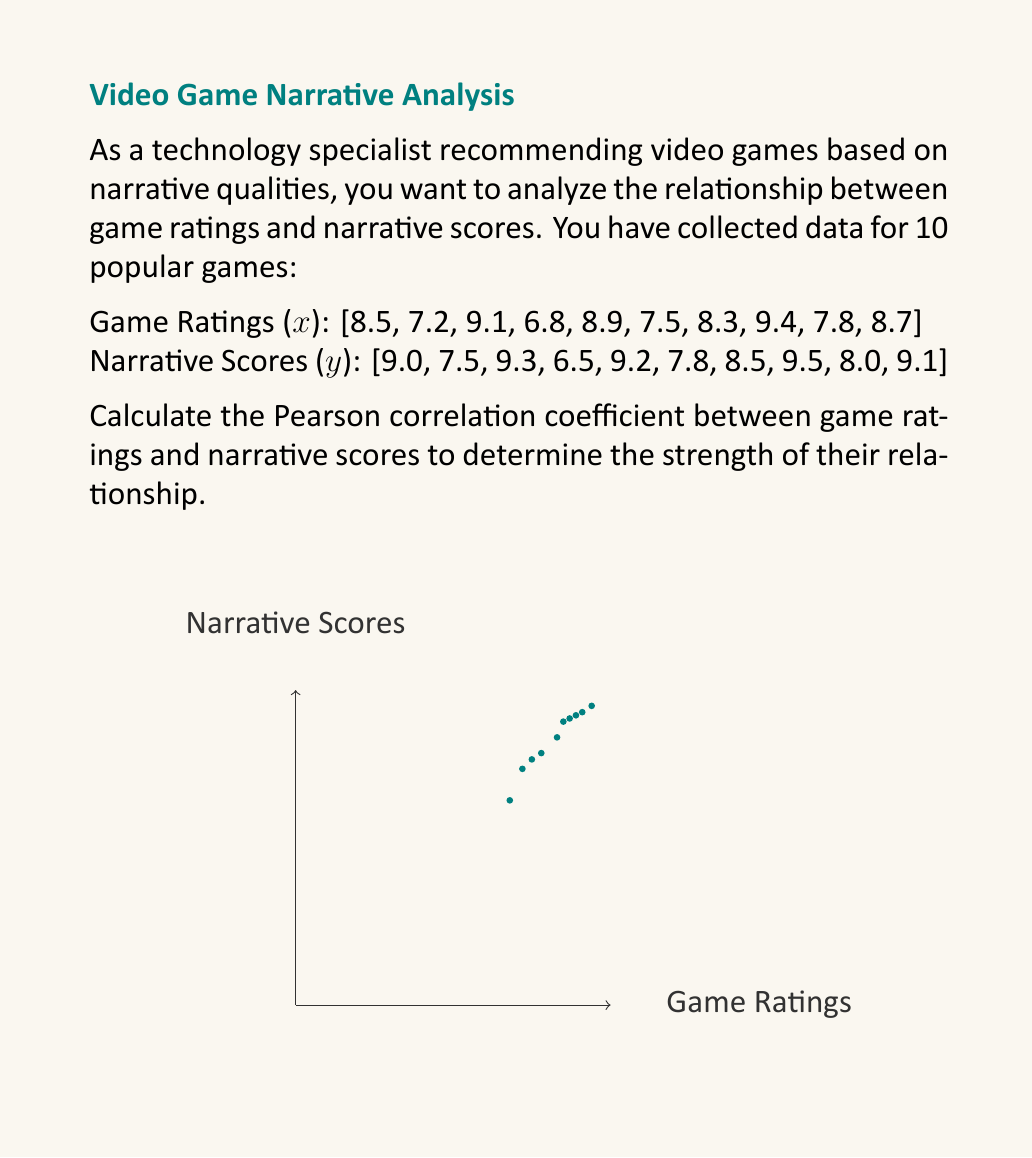Can you solve this math problem? To calculate the Pearson correlation coefficient (r), we'll use the formula:

$$ r = \frac{\sum_{i=1}^{n} (x_i - \bar{x})(y_i - \bar{y})}{\sqrt{\sum_{i=1}^{n} (x_i - \bar{x})^2 \sum_{i=1}^{n} (y_i - \bar{y})^2}} $$

Step 1: Calculate the means $\bar{x}$ and $\bar{y}$:
$\bar{x} = \frac{\sum_{i=1}^{n} x_i}{n} = \frac{82.2}{10} = 8.22$
$\bar{y} = \frac{\sum_{i=1}^{n} y_i}{n} = \frac{84.4}{10} = 8.44$

Step 2: Calculate $(x_i - \bar{x})$, $(y_i - \bar{y})$, $(x_i - \bar{x})^2$, $(y_i - \bar{y})^2$, and $(x_i - \bar{x})(y_i - \bar{y})$ for each pair.

Step 3: Sum up the values:
$\sum (x_i - \bar{x})(y_i - \bar{y}) = 7.348$
$\sum (x_i - \bar{x})^2 = 7.1956$
$\sum (y_i - \bar{y})^2 = 8.2024$

Step 4: Apply the formula:

$$ r = \frac{7.348}{\sqrt{7.1956 \times 8.2024}} = \frac{7.348}{\sqrt{59.0185}} = \frac{7.348}{7.6824} $$

Step 5: Calculate the final result:
$r \approx 0.9565$

This strong positive correlation indicates that game ratings and narrative scores are highly related in your dataset.
Answer: $r \approx 0.9565$ 